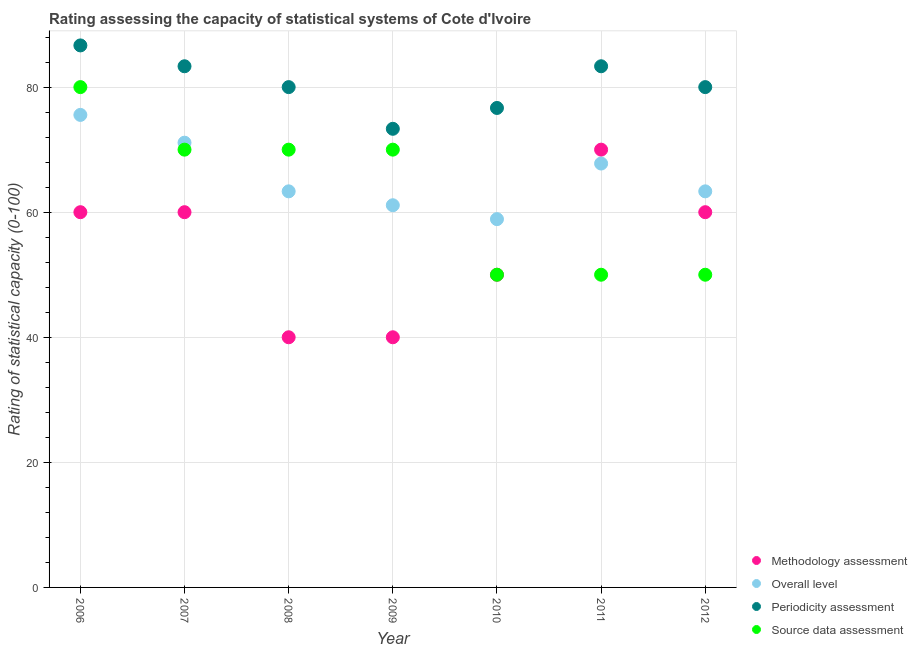How many different coloured dotlines are there?
Your answer should be compact. 4. Is the number of dotlines equal to the number of legend labels?
Provide a succinct answer. Yes. What is the source data assessment rating in 2011?
Make the answer very short. 50. Across all years, what is the maximum methodology assessment rating?
Your answer should be compact. 70. Across all years, what is the minimum source data assessment rating?
Provide a short and direct response. 50. In which year was the methodology assessment rating maximum?
Make the answer very short. 2011. What is the total periodicity assessment rating in the graph?
Make the answer very short. 563.33. What is the difference between the periodicity assessment rating in 2007 and that in 2009?
Keep it short and to the point. 10. What is the difference between the methodology assessment rating in 2011 and the periodicity assessment rating in 2008?
Make the answer very short. -10. What is the average periodicity assessment rating per year?
Give a very brief answer. 80.48. In the year 2009, what is the difference between the overall level rating and methodology assessment rating?
Offer a very short reply. 21.11. In how many years, is the source data assessment rating greater than 20?
Provide a succinct answer. 7. What is the ratio of the source data assessment rating in 2006 to that in 2008?
Your answer should be very brief. 1.14. Is the difference between the source data assessment rating in 2006 and 2008 greater than the difference between the overall level rating in 2006 and 2008?
Your answer should be compact. No. What is the difference between the highest and the second highest overall level rating?
Offer a very short reply. 4.44. What is the difference between the highest and the lowest methodology assessment rating?
Make the answer very short. 30. In how many years, is the source data assessment rating greater than the average source data assessment rating taken over all years?
Your response must be concise. 4. Is the sum of the methodology assessment rating in 2007 and 2012 greater than the maximum overall level rating across all years?
Provide a succinct answer. Yes. Is it the case that in every year, the sum of the methodology assessment rating and overall level rating is greater than the periodicity assessment rating?
Offer a very short reply. Yes. Is the source data assessment rating strictly greater than the periodicity assessment rating over the years?
Keep it short and to the point. No. How many years are there in the graph?
Your answer should be compact. 7. What is the difference between two consecutive major ticks on the Y-axis?
Keep it short and to the point. 20. Are the values on the major ticks of Y-axis written in scientific E-notation?
Offer a very short reply. No. Does the graph contain any zero values?
Your response must be concise. No. Does the graph contain grids?
Give a very brief answer. Yes. How are the legend labels stacked?
Keep it short and to the point. Vertical. What is the title of the graph?
Offer a terse response. Rating assessing the capacity of statistical systems of Cote d'Ivoire. Does "Terrestrial protected areas" appear as one of the legend labels in the graph?
Your answer should be compact. No. What is the label or title of the Y-axis?
Your response must be concise. Rating of statistical capacity (0-100). What is the Rating of statistical capacity (0-100) of Overall level in 2006?
Offer a very short reply. 75.56. What is the Rating of statistical capacity (0-100) in Periodicity assessment in 2006?
Provide a succinct answer. 86.67. What is the Rating of statistical capacity (0-100) of Source data assessment in 2006?
Ensure brevity in your answer.  80. What is the Rating of statistical capacity (0-100) of Overall level in 2007?
Your answer should be compact. 71.11. What is the Rating of statistical capacity (0-100) in Periodicity assessment in 2007?
Provide a succinct answer. 83.33. What is the Rating of statistical capacity (0-100) in Methodology assessment in 2008?
Offer a very short reply. 40. What is the Rating of statistical capacity (0-100) in Overall level in 2008?
Your response must be concise. 63.33. What is the Rating of statistical capacity (0-100) in Periodicity assessment in 2008?
Ensure brevity in your answer.  80. What is the Rating of statistical capacity (0-100) in Overall level in 2009?
Your response must be concise. 61.11. What is the Rating of statistical capacity (0-100) in Periodicity assessment in 2009?
Your answer should be very brief. 73.33. What is the Rating of statistical capacity (0-100) of Overall level in 2010?
Keep it short and to the point. 58.89. What is the Rating of statistical capacity (0-100) of Periodicity assessment in 2010?
Give a very brief answer. 76.67. What is the Rating of statistical capacity (0-100) in Overall level in 2011?
Offer a terse response. 67.78. What is the Rating of statistical capacity (0-100) of Periodicity assessment in 2011?
Offer a very short reply. 83.33. What is the Rating of statistical capacity (0-100) of Source data assessment in 2011?
Your answer should be compact. 50. What is the Rating of statistical capacity (0-100) of Methodology assessment in 2012?
Ensure brevity in your answer.  60. What is the Rating of statistical capacity (0-100) of Overall level in 2012?
Offer a terse response. 63.33. What is the Rating of statistical capacity (0-100) of Periodicity assessment in 2012?
Your answer should be very brief. 80. Across all years, what is the maximum Rating of statistical capacity (0-100) in Methodology assessment?
Your answer should be compact. 70. Across all years, what is the maximum Rating of statistical capacity (0-100) in Overall level?
Provide a short and direct response. 75.56. Across all years, what is the maximum Rating of statistical capacity (0-100) in Periodicity assessment?
Your response must be concise. 86.67. Across all years, what is the minimum Rating of statistical capacity (0-100) of Methodology assessment?
Give a very brief answer. 40. Across all years, what is the minimum Rating of statistical capacity (0-100) in Overall level?
Make the answer very short. 58.89. Across all years, what is the minimum Rating of statistical capacity (0-100) of Periodicity assessment?
Offer a very short reply. 73.33. Across all years, what is the minimum Rating of statistical capacity (0-100) of Source data assessment?
Offer a very short reply. 50. What is the total Rating of statistical capacity (0-100) of Methodology assessment in the graph?
Your response must be concise. 380. What is the total Rating of statistical capacity (0-100) of Overall level in the graph?
Your response must be concise. 461.11. What is the total Rating of statistical capacity (0-100) of Periodicity assessment in the graph?
Your answer should be compact. 563.33. What is the total Rating of statistical capacity (0-100) in Source data assessment in the graph?
Make the answer very short. 440. What is the difference between the Rating of statistical capacity (0-100) in Methodology assessment in 2006 and that in 2007?
Ensure brevity in your answer.  0. What is the difference between the Rating of statistical capacity (0-100) in Overall level in 2006 and that in 2007?
Offer a very short reply. 4.44. What is the difference between the Rating of statistical capacity (0-100) in Periodicity assessment in 2006 and that in 2007?
Your answer should be very brief. 3.33. What is the difference between the Rating of statistical capacity (0-100) of Source data assessment in 2006 and that in 2007?
Keep it short and to the point. 10. What is the difference between the Rating of statistical capacity (0-100) of Overall level in 2006 and that in 2008?
Your answer should be very brief. 12.22. What is the difference between the Rating of statistical capacity (0-100) of Source data assessment in 2006 and that in 2008?
Your response must be concise. 10. What is the difference between the Rating of statistical capacity (0-100) in Overall level in 2006 and that in 2009?
Offer a terse response. 14.44. What is the difference between the Rating of statistical capacity (0-100) in Periodicity assessment in 2006 and that in 2009?
Provide a succinct answer. 13.33. What is the difference between the Rating of statistical capacity (0-100) in Methodology assessment in 2006 and that in 2010?
Ensure brevity in your answer.  10. What is the difference between the Rating of statistical capacity (0-100) in Overall level in 2006 and that in 2010?
Provide a succinct answer. 16.67. What is the difference between the Rating of statistical capacity (0-100) of Source data assessment in 2006 and that in 2010?
Your response must be concise. 30. What is the difference between the Rating of statistical capacity (0-100) of Overall level in 2006 and that in 2011?
Give a very brief answer. 7.78. What is the difference between the Rating of statistical capacity (0-100) in Periodicity assessment in 2006 and that in 2011?
Offer a very short reply. 3.33. What is the difference between the Rating of statistical capacity (0-100) of Source data assessment in 2006 and that in 2011?
Provide a succinct answer. 30. What is the difference between the Rating of statistical capacity (0-100) of Overall level in 2006 and that in 2012?
Your answer should be very brief. 12.22. What is the difference between the Rating of statistical capacity (0-100) in Source data assessment in 2006 and that in 2012?
Give a very brief answer. 30. What is the difference between the Rating of statistical capacity (0-100) in Overall level in 2007 and that in 2008?
Your answer should be very brief. 7.78. What is the difference between the Rating of statistical capacity (0-100) in Periodicity assessment in 2007 and that in 2008?
Offer a very short reply. 3.33. What is the difference between the Rating of statistical capacity (0-100) in Methodology assessment in 2007 and that in 2009?
Offer a terse response. 20. What is the difference between the Rating of statistical capacity (0-100) in Periodicity assessment in 2007 and that in 2009?
Offer a terse response. 10. What is the difference between the Rating of statistical capacity (0-100) in Overall level in 2007 and that in 2010?
Keep it short and to the point. 12.22. What is the difference between the Rating of statistical capacity (0-100) in Periodicity assessment in 2007 and that in 2010?
Ensure brevity in your answer.  6.67. What is the difference between the Rating of statistical capacity (0-100) of Methodology assessment in 2007 and that in 2011?
Provide a short and direct response. -10. What is the difference between the Rating of statistical capacity (0-100) in Source data assessment in 2007 and that in 2011?
Provide a short and direct response. 20. What is the difference between the Rating of statistical capacity (0-100) of Methodology assessment in 2007 and that in 2012?
Keep it short and to the point. 0. What is the difference between the Rating of statistical capacity (0-100) in Overall level in 2007 and that in 2012?
Your answer should be very brief. 7.78. What is the difference between the Rating of statistical capacity (0-100) of Methodology assessment in 2008 and that in 2009?
Keep it short and to the point. 0. What is the difference between the Rating of statistical capacity (0-100) of Overall level in 2008 and that in 2009?
Provide a short and direct response. 2.22. What is the difference between the Rating of statistical capacity (0-100) in Methodology assessment in 2008 and that in 2010?
Your answer should be compact. -10. What is the difference between the Rating of statistical capacity (0-100) of Overall level in 2008 and that in 2010?
Keep it short and to the point. 4.44. What is the difference between the Rating of statistical capacity (0-100) in Periodicity assessment in 2008 and that in 2010?
Offer a terse response. 3.33. What is the difference between the Rating of statistical capacity (0-100) of Methodology assessment in 2008 and that in 2011?
Provide a succinct answer. -30. What is the difference between the Rating of statistical capacity (0-100) in Overall level in 2008 and that in 2011?
Keep it short and to the point. -4.44. What is the difference between the Rating of statistical capacity (0-100) in Source data assessment in 2008 and that in 2011?
Offer a terse response. 20. What is the difference between the Rating of statistical capacity (0-100) in Overall level in 2008 and that in 2012?
Keep it short and to the point. 0. What is the difference between the Rating of statistical capacity (0-100) of Periodicity assessment in 2008 and that in 2012?
Offer a terse response. 0. What is the difference between the Rating of statistical capacity (0-100) in Overall level in 2009 and that in 2010?
Your response must be concise. 2.22. What is the difference between the Rating of statistical capacity (0-100) in Overall level in 2009 and that in 2011?
Offer a terse response. -6.67. What is the difference between the Rating of statistical capacity (0-100) of Periodicity assessment in 2009 and that in 2011?
Make the answer very short. -10. What is the difference between the Rating of statistical capacity (0-100) of Overall level in 2009 and that in 2012?
Provide a short and direct response. -2.22. What is the difference between the Rating of statistical capacity (0-100) in Periodicity assessment in 2009 and that in 2012?
Keep it short and to the point. -6.67. What is the difference between the Rating of statistical capacity (0-100) of Overall level in 2010 and that in 2011?
Your answer should be very brief. -8.89. What is the difference between the Rating of statistical capacity (0-100) of Periodicity assessment in 2010 and that in 2011?
Offer a very short reply. -6.67. What is the difference between the Rating of statistical capacity (0-100) of Overall level in 2010 and that in 2012?
Your answer should be compact. -4.44. What is the difference between the Rating of statistical capacity (0-100) in Periodicity assessment in 2010 and that in 2012?
Keep it short and to the point. -3.33. What is the difference between the Rating of statistical capacity (0-100) in Methodology assessment in 2011 and that in 2012?
Ensure brevity in your answer.  10. What is the difference between the Rating of statistical capacity (0-100) in Overall level in 2011 and that in 2012?
Keep it short and to the point. 4.44. What is the difference between the Rating of statistical capacity (0-100) in Periodicity assessment in 2011 and that in 2012?
Offer a terse response. 3.33. What is the difference between the Rating of statistical capacity (0-100) of Source data assessment in 2011 and that in 2012?
Offer a very short reply. 0. What is the difference between the Rating of statistical capacity (0-100) in Methodology assessment in 2006 and the Rating of statistical capacity (0-100) in Overall level in 2007?
Your answer should be compact. -11.11. What is the difference between the Rating of statistical capacity (0-100) of Methodology assessment in 2006 and the Rating of statistical capacity (0-100) of Periodicity assessment in 2007?
Your response must be concise. -23.33. What is the difference between the Rating of statistical capacity (0-100) of Methodology assessment in 2006 and the Rating of statistical capacity (0-100) of Source data assessment in 2007?
Your response must be concise. -10. What is the difference between the Rating of statistical capacity (0-100) of Overall level in 2006 and the Rating of statistical capacity (0-100) of Periodicity assessment in 2007?
Offer a terse response. -7.78. What is the difference between the Rating of statistical capacity (0-100) of Overall level in 2006 and the Rating of statistical capacity (0-100) of Source data assessment in 2007?
Your response must be concise. 5.56. What is the difference between the Rating of statistical capacity (0-100) in Periodicity assessment in 2006 and the Rating of statistical capacity (0-100) in Source data assessment in 2007?
Offer a terse response. 16.67. What is the difference between the Rating of statistical capacity (0-100) of Methodology assessment in 2006 and the Rating of statistical capacity (0-100) of Overall level in 2008?
Provide a short and direct response. -3.33. What is the difference between the Rating of statistical capacity (0-100) in Methodology assessment in 2006 and the Rating of statistical capacity (0-100) in Periodicity assessment in 2008?
Provide a short and direct response. -20. What is the difference between the Rating of statistical capacity (0-100) of Overall level in 2006 and the Rating of statistical capacity (0-100) of Periodicity assessment in 2008?
Offer a terse response. -4.44. What is the difference between the Rating of statistical capacity (0-100) of Overall level in 2006 and the Rating of statistical capacity (0-100) of Source data assessment in 2008?
Keep it short and to the point. 5.56. What is the difference between the Rating of statistical capacity (0-100) of Periodicity assessment in 2006 and the Rating of statistical capacity (0-100) of Source data assessment in 2008?
Make the answer very short. 16.67. What is the difference between the Rating of statistical capacity (0-100) in Methodology assessment in 2006 and the Rating of statistical capacity (0-100) in Overall level in 2009?
Offer a terse response. -1.11. What is the difference between the Rating of statistical capacity (0-100) of Methodology assessment in 2006 and the Rating of statistical capacity (0-100) of Periodicity assessment in 2009?
Provide a short and direct response. -13.33. What is the difference between the Rating of statistical capacity (0-100) of Overall level in 2006 and the Rating of statistical capacity (0-100) of Periodicity assessment in 2009?
Your answer should be very brief. 2.22. What is the difference between the Rating of statistical capacity (0-100) in Overall level in 2006 and the Rating of statistical capacity (0-100) in Source data assessment in 2009?
Offer a very short reply. 5.56. What is the difference between the Rating of statistical capacity (0-100) of Periodicity assessment in 2006 and the Rating of statistical capacity (0-100) of Source data assessment in 2009?
Ensure brevity in your answer.  16.67. What is the difference between the Rating of statistical capacity (0-100) of Methodology assessment in 2006 and the Rating of statistical capacity (0-100) of Periodicity assessment in 2010?
Your answer should be very brief. -16.67. What is the difference between the Rating of statistical capacity (0-100) in Methodology assessment in 2006 and the Rating of statistical capacity (0-100) in Source data assessment in 2010?
Provide a succinct answer. 10. What is the difference between the Rating of statistical capacity (0-100) in Overall level in 2006 and the Rating of statistical capacity (0-100) in Periodicity assessment in 2010?
Your answer should be very brief. -1.11. What is the difference between the Rating of statistical capacity (0-100) of Overall level in 2006 and the Rating of statistical capacity (0-100) of Source data assessment in 2010?
Provide a succinct answer. 25.56. What is the difference between the Rating of statistical capacity (0-100) of Periodicity assessment in 2006 and the Rating of statistical capacity (0-100) of Source data assessment in 2010?
Ensure brevity in your answer.  36.67. What is the difference between the Rating of statistical capacity (0-100) of Methodology assessment in 2006 and the Rating of statistical capacity (0-100) of Overall level in 2011?
Offer a terse response. -7.78. What is the difference between the Rating of statistical capacity (0-100) of Methodology assessment in 2006 and the Rating of statistical capacity (0-100) of Periodicity assessment in 2011?
Keep it short and to the point. -23.33. What is the difference between the Rating of statistical capacity (0-100) in Methodology assessment in 2006 and the Rating of statistical capacity (0-100) in Source data assessment in 2011?
Provide a succinct answer. 10. What is the difference between the Rating of statistical capacity (0-100) of Overall level in 2006 and the Rating of statistical capacity (0-100) of Periodicity assessment in 2011?
Make the answer very short. -7.78. What is the difference between the Rating of statistical capacity (0-100) in Overall level in 2006 and the Rating of statistical capacity (0-100) in Source data assessment in 2011?
Give a very brief answer. 25.56. What is the difference between the Rating of statistical capacity (0-100) in Periodicity assessment in 2006 and the Rating of statistical capacity (0-100) in Source data assessment in 2011?
Your response must be concise. 36.67. What is the difference between the Rating of statistical capacity (0-100) in Overall level in 2006 and the Rating of statistical capacity (0-100) in Periodicity assessment in 2012?
Ensure brevity in your answer.  -4.44. What is the difference between the Rating of statistical capacity (0-100) in Overall level in 2006 and the Rating of statistical capacity (0-100) in Source data assessment in 2012?
Ensure brevity in your answer.  25.56. What is the difference between the Rating of statistical capacity (0-100) in Periodicity assessment in 2006 and the Rating of statistical capacity (0-100) in Source data assessment in 2012?
Your answer should be very brief. 36.67. What is the difference between the Rating of statistical capacity (0-100) of Methodology assessment in 2007 and the Rating of statistical capacity (0-100) of Overall level in 2008?
Make the answer very short. -3.33. What is the difference between the Rating of statistical capacity (0-100) in Methodology assessment in 2007 and the Rating of statistical capacity (0-100) in Source data assessment in 2008?
Your answer should be very brief. -10. What is the difference between the Rating of statistical capacity (0-100) of Overall level in 2007 and the Rating of statistical capacity (0-100) of Periodicity assessment in 2008?
Your response must be concise. -8.89. What is the difference between the Rating of statistical capacity (0-100) in Overall level in 2007 and the Rating of statistical capacity (0-100) in Source data assessment in 2008?
Provide a succinct answer. 1.11. What is the difference between the Rating of statistical capacity (0-100) in Periodicity assessment in 2007 and the Rating of statistical capacity (0-100) in Source data assessment in 2008?
Give a very brief answer. 13.33. What is the difference between the Rating of statistical capacity (0-100) of Methodology assessment in 2007 and the Rating of statistical capacity (0-100) of Overall level in 2009?
Make the answer very short. -1.11. What is the difference between the Rating of statistical capacity (0-100) of Methodology assessment in 2007 and the Rating of statistical capacity (0-100) of Periodicity assessment in 2009?
Offer a terse response. -13.33. What is the difference between the Rating of statistical capacity (0-100) in Methodology assessment in 2007 and the Rating of statistical capacity (0-100) in Source data assessment in 2009?
Offer a very short reply. -10. What is the difference between the Rating of statistical capacity (0-100) in Overall level in 2007 and the Rating of statistical capacity (0-100) in Periodicity assessment in 2009?
Keep it short and to the point. -2.22. What is the difference between the Rating of statistical capacity (0-100) of Overall level in 2007 and the Rating of statistical capacity (0-100) of Source data assessment in 2009?
Offer a very short reply. 1.11. What is the difference between the Rating of statistical capacity (0-100) of Periodicity assessment in 2007 and the Rating of statistical capacity (0-100) of Source data assessment in 2009?
Offer a very short reply. 13.33. What is the difference between the Rating of statistical capacity (0-100) of Methodology assessment in 2007 and the Rating of statistical capacity (0-100) of Periodicity assessment in 2010?
Your response must be concise. -16.67. What is the difference between the Rating of statistical capacity (0-100) in Overall level in 2007 and the Rating of statistical capacity (0-100) in Periodicity assessment in 2010?
Your response must be concise. -5.56. What is the difference between the Rating of statistical capacity (0-100) of Overall level in 2007 and the Rating of statistical capacity (0-100) of Source data assessment in 2010?
Ensure brevity in your answer.  21.11. What is the difference between the Rating of statistical capacity (0-100) of Periodicity assessment in 2007 and the Rating of statistical capacity (0-100) of Source data assessment in 2010?
Your answer should be compact. 33.33. What is the difference between the Rating of statistical capacity (0-100) of Methodology assessment in 2007 and the Rating of statistical capacity (0-100) of Overall level in 2011?
Make the answer very short. -7.78. What is the difference between the Rating of statistical capacity (0-100) of Methodology assessment in 2007 and the Rating of statistical capacity (0-100) of Periodicity assessment in 2011?
Keep it short and to the point. -23.33. What is the difference between the Rating of statistical capacity (0-100) of Methodology assessment in 2007 and the Rating of statistical capacity (0-100) of Source data assessment in 2011?
Provide a succinct answer. 10. What is the difference between the Rating of statistical capacity (0-100) in Overall level in 2007 and the Rating of statistical capacity (0-100) in Periodicity assessment in 2011?
Provide a short and direct response. -12.22. What is the difference between the Rating of statistical capacity (0-100) of Overall level in 2007 and the Rating of statistical capacity (0-100) of Source data assessment in 2011?
Your response must be concise. 21.11. What is the difference between the Rating of statistical capacity (0-100) in Periodicity assessment in 2007 and the Rating of statistical capacity (0-100) in Source data assessment in 2011?
Offer a terse response. 33.33. What is the difference between the Rating of statistical capacity (0-100) in Overall level in 2007 and the Rating of statistical capacity (0-100) in Periodicity assessment in 2012?
Your response must be concise. -8.89. What is the difference between the Rating of statistical capacity (0-100) of Overall level in 2007 and the Rating of statistical capacity (0-100) of Source data assessment in 2012?
Your answer should be compact. 21.11. What is the difference between the Rating of statistical capacity (0-100) of Periodicity assessment in 2007 and the Rating of statistical capacity (0-100) of Source data assessment in 2012?
Your answer should be compact. 33.33. What is the difference between the Rating of statistical capacity (0-100) of Methodology assessment in 2008 and the Rating of statistical capacity (0-100) of Overall level in 2009?
Keep it short and to the point. -21.11. What is the difference between the Rating of statistical capacity (0-100) in Methodology assessment in 2008 and the Rating of statistical capacity (0-100) in Periodicity assessment in 2009?
Make the answer very short. -33.33. What is the difference between the Rating of statistical capacity (0-100) in Methodology assessment in 2008 and the Rating of statistical capacity (0-100) in Source data assessment in 2009?
Your answer should be compact. -30. What is the difference between the Rating of statistical capacity (0-100) of Overall level in 2008 and the Rating of statistical capacity (0-100) of Periodicity assessment in 2009?
Provide a short and direct response. -10. What is the difference between the Rating of statistical capacity (0-100) in Overall level in 2008 and the Rating of statistical capacity (0-100) in Source data assessment in 2009?
Your answer should be very brief. -6.67. What is the difference between the Rating of statistical capacity (0-100) in Periodicity assessment in 2008 and the Rating of statistical capacity (0-100) in Source data assessment in 2009?
Give a very brief answer. 10. What is the difference between the Rating of statistical capacity (0-100) in Methodology assessment in 2008 and the Rating of statistical capacity (0-100) in Overall level in 2010?
Provide a succinct answer. -18.89. What is the difference between the Rating of statistical capacity (0-100) of Methodology assessment in 2008 and the Rating of statistical capacity (0-100) of Periodicity assessment in 2010?
Keep it short and to the point. -36.67. What is the difference between the Rating of statistical capacity (0-100) in Overall level in 2008 and the Rating of statistical capacity (0-100) in Periodicity assessment in 2010?
Provide a succinct answer. -13.33. What is the difference between the Rating of statistical capacity (0-100) in Overall level in 2008 and the Rating of statistical capacity (0-100) in Source data assessment in 2010?
Make the answer very short. 13.33. What is the difference between the Rating of statistical capacity (0-100) in Methodology assessment in 2008 and the Rating of statistical capacity (0-100) in Overall level in 2011?
Give a very brief answer. -27.78. What is the difference between the Rating of statistical capacity (0-100) of Methodology assessment in 2008 and the Rating of statistical capacity (0-100) of Periodicity assessment in 2011?
Offer a terse response. -43.33. What is the difference between the Rating of statistical capacity (0-100) in Overall level in 2008 and the Rating of statistical capacity (0-100) in Source data assessment in 2011?
Keep it short and to the point. 13.33. What is the difference between the Rating of statistical capacity (0-100) in Periodicity assessment in 2008 and the Rating of statistical capacity (0-100) in Source data assessment in 2011?
Ensure brevity in your answer.  30. What is the difference between the Rating of statistical capacity (0-100) of Methodology assessment in 2008 and the Rating of statistical capacity (0-100) of Overall level in 2012?
Offer a terse response. -23.33. What is the difference between the Rating of statistical capacity (0-100) in Overall level in 2008 and the Rating of statistical capacity (0-100) in Periodicity assessment in 2012?
Make the answer very short. -16.67. What is the difference between the Rating of statistical capacity (0-100) in Overall level in 2008 and the Rating of statistical capacity (0-100) in Source data assessment in 2012?
Your answer should be very brief. 13.33. What is the difference between the Rating of statistical capacity (0-100) in Methodology assessment in 2009 and the Rating of statistical capacity (0-100) in Overall level in 2010?
Keep it short and to the point. -18.89. What is the difference between the Rating of statistical capacity (0-100) in Methodology assessment in 2009 and the Rating of statistical capacity (0-100) in Periodicity assessment in 2010?
Your response must be concise. -36.67. What is the difference between the Rating of statistical capacity (0-100) in Overall level in 2009 and the Rating of statistical capacity (0-100) in Periodicity assessment in 2010?
Offer a very short reply. -15.56. What is the difference between the Rating of statistical capacity (0-100) of Overall level in 2009 and the Rating of statistical capacity (0-100) of Source data assessment in 2010?
Your answer should be very brief. 11.11. What is the difference between the Rating of statistical capacity (0-100) in Periodicity assessment in 2009 and the Rating of statistical capacity (0-100) in Source data assessment in 2010?
Your answer should be compact. 23.33. What is the difference between the Rating of statistical capacity (0-100) of Methodology assessment in 2009 and the Rating of statistical capacity (0-100) of Overall level in 2011?
Give a very brief answer. -27.78. What is the difference between the Rating of statistical capacity (0-100) in Methodology assessment in 2009 and the Rating of statistical capacity (0-100) in Periodicity assessment in 2011?
Your answer should be very brief. -43.33. What is the difference between the Rating of statistical capacity (0-100) of Methodology assessment in 2009 and the Rating of statistical capacity (0-100) of Source data assessment in 2011?
Ensure brevity in your answer.  -10. What is the difference between the Rating of statistical capacity (0-100) in Overall level in 2009 and the Rating of statistical capacity (0-100) in Periodicity assessment in 2011?
Offer a very short reply. -22.22. What is the difference between the Rating of statistical capacity (0-100) of Overall level in 2009 and the Rating of statistical capacity (0-100) of Source data assessment in 2011?
Your response must be concise. 11.11. What is the difference between the Rating of statistical capacity (0-100) of Periodicity assessment in 2009 and the Rating of statistical capacity (0-100) of Source data assessment in 2011?
Keep it short and to the point. 23.33. What is the difference between the Rating of statistical capacity (0-100) in Methodology assessment in 2009 and the Rating of statistical capacity (0-100) in Overall level in 2012?
Keep it short and to the point. -23.33. What is the difference between the Rating of statistical capacity (0-100) in Methodology assessment in 2009 and the Rating of statistical capacity (0-100) in Periodicity assessment in 2012?
Keep it short and to the point. -40. What is the difference between the Rating of statistical capacity (0-100) of Overall level in 2009 and the Rating of statistical capacity (0-100) of Periodicity assessment in 2012?
Offer a very short reply. -18.89. What is the difference between the Rating of statistical capacity (0-100) in Overall level in 2009 and the Rating of statistical capacity (0-100) in Source data assessment in 2012?
Keep it short and to the point. 11.11. What is the difference between the Rating of statistical capacity (0-100) of Periodicity assessment in 2009 and the Rating of statistical capacity (0-100) of Source data assessment in 2012?
Your response must be concise. 23.33. What is the difference between the Rating of statistical capacity (0-100) in Methodology assessment in 2010 and the Rating of statistical capacity (0-100) in Overall level in 2011?
Make the answer very short. -17.78. What is the difference between the Rating of statistical capacity (0-100) of Methodology assessment in 2010 and the Rating of statistical capacity (0-100) of Periodicity assessment in 2011?
Offer a terse response. -33.33. What is the difference between the Rating of statistical capacity (0-100) of Methodology assessment in 2010 and the Rating of statistical capacity (0-100) of Source data assessment in 2011?
Provide a succinct answer. 0. What is the difference between the Rating of statistical capacity (0-100) in Overall level in 2010 and the Rating of statistical capacity (0-100) in Periodicity assessment in 2011?
Your response must be concise. -24.44. What is the difference between the Rating of statistical capacity (0-100) of Overall level in 2010 and the Rating of statistical capacity (0-100) of Source data assessment in 2011?
Give a very brief answer. 8.89. What is the difference between the Rating of statistical capacity (0-100) in Periodicity assessment in 2010 and the Rating of statistical capacity (0-100) in Source data assessment in 2011?
Ensure brevity in your answer.  26.67. What is the difference between the Rating of statistical capacity (0-100) of Methodology assessment in 2010 and the Rating of statistical capacity (0-100) of Overall level in 2012?
Offer a terse response. -13.33. What is the difference between the Rating of statistical capacity (0-100) in Methodology assessment in 2010 and the Rating of statistical capacity (0-100) in Periodicity assessment in 2012?
Offer a terse response. -30. What is the difference between the Rating of statistical capacity (0-100) of Overall level in 2010 and the Rating of statistical capacity (0-100) of Periodicity assessment in 2012?
Give a very brief answer. -21.11. What is the difference between the Rating of statistical capacity (0-100) of Overall level in 2010 and the Rating of statistical capacity (0-100) of Source data assessment in 2012?
Provide a succinct answer. 8.89. What is the difference between the Rating of statistical capacity (0-100) in Periodicity assessment in 2010 and the Rating of statistical capacity (0-100) in Source data assessment in 2012?
Offer a very short reply. 26.67. What is the difference between the Rating of statistical capacity (0-100) of Methodology assessment in 2011 and the Rating of statistical capacity (0-100) of Overall level in 2012?
Offer a very short reply. 6.67. What is the difference between the Rating of statistical capacity (0-100) of Methodology assessment in 2011 and the Rating of statistical capacity (0-100) of Periodicity assessment in 2012?
Provide a short and direct response. -10. What is the difference between the Rating of statistical capacity (0-100) of Methodology assessment in 2011 and the Rating of statistical capacity (0-100) of Source data assessment in 2012?
Give a very brief answer. 20. What is the difference between the Rating of statistical capacity (0-100) in Overall level in 2011 and the Rating of statistical capacity (0-100) in Periodicity assessment in 2012?
Keep it short and to the point. -12.22. What is the difference between the Rating of statistical capacity (0-100) of Overall level in 2011 and the Rating of statistical capacity (0-100) of Source data assessment in 2012?
Provide a short and direct response. 17.78. What is the difference between the Rating of statistical capacity (0-100) of Periodicity assessment in 2011 and the Rating of statistical capacity (0-100) of Source data assessment in 2012?
Your answer should be compact. 33.33. What is the average Rating of statistical capacity (0-100) of Methodology assessment per year?
Your answer should be compact. 54.29. What is the average Rating of statistical capacity (0-100) in Overall level per year?
Offer a terse response. 65.87. What is the average Rating of statistical capacity (0-100) of Periodicity assessment per year?
Your answer should be compact. 80.48. What is the average Rating of statistical capacity (0-100) in Source data assessment per year?
Your answer should be very brief. 62.86. In the year 2006, what is the difference between the Rating of statistical capacity (0-100) of Methodology assessment and Rating of statistical capacity (0-100) of Overall level?
Offer a terse response. -15.56. In the year 2006, what is the difference between the Rating of statistical capacity (0-100) of Methodology assessment and Rating of statistical capacity (0-100) of Periodicity assessment?
Give a very brief answer. -26.67. In the year 2006, what is the difference between the Rating of statistical capacity (0-100) in Overall level and Rating of statistical capacity (0-100) in Periodicity assessment?
Your response must be concise. -11.11. In the year 2006, what is the difference between the Rating of statistical capacity (0-100) of Overall level and Rating of statistical capacity (0-100) of Source data assessment?
Keep it short and to the point. -4.44. In the year 2006, what is the difference between the Rating of statistical capacity (0-100) in Periodicity assessment and Rating of statistical capacity (0-100) in Source data assessment?
Your answer should be compact. 6.67. In the year 2007, what is the difference between the Rating of statistical capacity (0-100) in Methodology assessment and Rating of statistical capacity (0-100) in Overall level?
Ensure brevity in your answer.  -11.11. In the year 2007, what is the difference between the Rating of statistical capacity (0-100) in Methodology assessment and Rating of statistical capacity (0-100) in Periodicity assessment?
Your response must be concise. -23.33. In the year 2007, what is the difference between the Rating of statistical capacity (0-100) in Overall level and Rating of statistical capacity (0-100) in Periodicity assessment?
Your response must be concise. -12.22. In the year 2007, what is the difference between the Rating of statistical capacity (0-100) in Overall level and Rating of statistical capacity (0-100) in Source data assessment?
Your answer should be compact. 1.11. In the year 2007, what is the difference between the Rating of statistical capacity (0-100) of Periodicity assessment and Rating of statistical capacity (0-100) of Source data assessment?
Offer a terse response. 13.33. In the year 2008, what is the difference between the Rating of statistical capacity (0-100) in Methodology assessment and Rating of statistical capacity (0-100) in Overall level?
Make the answer very short. -23.33. In the year 2008, what is the difference between the Rating of statistical capacity (0-100) of Methodology assessment and Rating of statistical capacity (0-100) of Periodicity assessment?
Keep it short and to the point. -40. In the year 2008, what is the difference between the Rating of statistical capacity (0-100) of Overall level and Rating of statistical capacity (0-100) of Periodicity assessment?
Offer a very short reply. -16.67. In the year 2008, what is the difference between the Rating of statistical capacity (0-100) of Overall level and Rating of statistical capacity (0-100) of Source data assessment?
Keep it short and to the point. -6.67. In the year 2008, what is the difference between the Rating of statistical capacity (0-100) in Periodicity assessment and Rating of statistical capacity (0-100) in Source data assessment?
Ensure brevity in your answer.  10. In the year 2009, what is the difference between the Rating of statistical capacity (0-100) in Methodology assessment and Rating of statistical capacity (0-100) in Overall level?
Keep it short and to the point. -21.11. In the year 2009, what is the difference between the Rating of statistical capacity (0-100) of Methodology assessment and Rating of statistical capacity (0-100) of Periodicity assessment?
Make the answer very short. -33.33. In the year 2009, what is the difference between the Rating of statistical capacity (0-100) of Methodology assessment and Rating of statistical capacity (0-100) of Source data assessment?
Ensure brevity in your answer.  -30. In the year 2009, what is the difference between the Rating of statistical capacity (0-100) of Overall level and Rating of statistical capacity (0-100) of Periodicity assessment?
Provide a succinct answer. -12.22. In the year 2009, what is the difference between the Rating of statistical capacity (0-100) of Overall level and Rating of statistical capacity (0-100) of Source data assessment?
Keep it short and to the point. -8.89. In the year 2009, what is the difference between the Rating of statistical capacity (0-100) in Periodicity assessment and Rating of statistical capacity (0-100) in Source data assessment?
Offer a very short reply. 3.33. In the year 2010, what is the difference between the Rating of statistical capacity (0-100) in Methodology assessment and Rating of statistical capacity (0-100) in Overall level?
Give a very brief answer. -8.89. In the year 2010, what is the difference between the Rating of statistical capacity (0-100) of Methodology assessment and Rating of statistical capacity (0-100) of Periodicity assessment?
Ensure brevity in your answer.  -26.67. In the year 2010, what is the difference between the Rating of statistical capacity (0-100) in Overall level and Rating of statistical capacity (0-100) in Periodicity assessment?
Make the answer very short. -17.78. In the year 2010, what is the difference between the Rating of statistical capacity (0-100) in Overall level and Rating of statistical capacity (0-100) in Source data assessment?
Ensure brevity in your answer.  8.89. In the year 2010, what is the difference between the Rating of statistical capacity (0-100) in Periodicity assessment and Rating of statistical capacity (0-100) in Source data assessment?
Offer a terse response. 26.67. In the year 2011, what is the difference between the Rating of statistical capacity (0-100) of Methodology assessment and Rating of statistical capacity (0-100) of Overall level?
Your answer should be compact. 2.22. In the year 2011, what is the difference between the Rating of statistical capacity (0-100) of Methodology assessment and Rating of statistical capacity (0-100) of Periodicity assessment?
Provide a succinct answer. -13.33. In the year 2011, what is the difference between the Rating of statistical capacity (0-100) of Overall level and Rating of statistical capacity (0-100) of Periodicity assessment?
Offer a terse response. -15.56. In the year 2011, what is the difference between the Rating of statistical capacity (0-100) in Overall level and Rating of statistical capacity (0-100) in Source data assessment?
Your response must be concise. 17.78. In the year 2011, what is the difference between the Rating of statistical capacity (0-100) of Periodicity assessment and Rating of statistical capacity (0-100) of Source data assessment?
Keep it short and to the point. 33.33. In the year 2012, what is the difference between the Rating of statistical capacity (0-100) of Methodology assessment and Rating of statistical capacity (0-100) of Overall level?
Keep it short and to the point. -3.33. In the year 2012, what is the difference between the Rating of statistical capacity (0-100) in Methodology assessment and Rating of statistical capacity (0-100) in Periodicity assessment?
Provide a succinct answer. -20. In the year 2012, what is the difference between the Rating of statistical capacity (0-100) in Overall level and Rating of statistical capacity (0-100) in Periodicity assessment?
Your response must be concise. -16.67. In the year 2012, what is the difference between the Rating of statistical capacity (0-100) in Overall level and Rating of statistical capacity (0-100) in Source data assessment?
Your answer should be compact. 13.33. In the year 2012, what is the difference between the Rating of statistical capacity (0-100) in Periodicity assessment and Rating of statistical capacity (0-100) in Source data assessment?
Provide a short and direct response. 30. What is the ratio of the Rating of statistical capacity (0-100) of Methodology assessment in 2006 to that in 2007?
Your response must be concise. 1. What is the ratio of the Rating of statistical capacity (0-100) of Periodicity assessment in 2006 to that in 2007?
Your response must be concise. 1.04. What is the ratio of the Rating of statistical capacity (0-100) in Source data assessment in 2006 to that in 2007?
Your answer should be very brief. 1.14. What is the ratio of the Rating of statistical capacity (0-100) of Overall level in 2006 to that in 2008?
Offer a very short reply. 1.19. What is the ratio of the Rating of statistical capacity (0-100) of Source data assessment in 2006 to that in 2008?
Your answer should be compact. 1.14. What is the ratio of the Rating of statistical capacity (0-100) of Overall level in 2006 to that in 2009?
Offer a terse response. 1.24. What is the ratio of the Rating of statistical capacity (0-100) of Periodicity assessment in 2006 to that in 2009?
Make the answer very short. 1.18. What is the ratio of the Rating of statistical capacity (0-100) of Overall level in 2006 to that in 2010?
Keep it short and to the point. 1.28. What is the ratio of the Rating of statistical capacity (0-100) in Periodicity assessment in 2006 to that in 2010?
Offer a terse response. 1.13. What is the ratio of the Rating of statistical capacity (0-100) in Overall level in 2006 to that in 2011?
Offer a very short reply. 1.11. What is the ratio of the Rating of statistical capacity (0-100) of Periodicity assessment in 2006 to that in 2011?
Your answer should be compact. 1.04. What is the ratio of the Rating of statistical capacity (0-100) in Source data assessment in 2006 to that in 2011?
Offer a very short reply. 1.6. What is the ratio of the Rating of statistical capacity (0-100) of Overall level in 2006 to that in 2012?
Keep it short and to the point. 1.19. What is the ratio of the Rating of statistical capacity (0-100) in Periodicity assessment in 2006 to that in 2012?
Provide a succinct answer. 1.08. What is the ratio of the Rating of statistical capacity (0-100) of Overall level in 2007 to that in 2008?
Your response must be concise. 1.12. What is the ratio of the Rating of statistical capacity (0-100) of Periodicity assessment in 2007 to that in 2008?
Your answer should be very brief. 1.04. What is the ratio of the Rating of statistical capacity (0-100) of Source data assessment in 2007 to that in 2008?
Keep it short and to the point. 1. What is the ratio of the Rating of statistical capacity (0-100) of Overall level in 2007 to that in 2009?
Provide a short and direct response. 1.16. What is the ratio of the Rating of statistical capacity (0-100) in Periodicity assessment in 2007 to that in 2009?
Provide a succinct answer. 1.14. What is the ratio of the Rating of statistical capacity (0-100) in Methodology assessment in 2007 to that in 2010?
Your answer should be very brief. 1.2. What is the ratio of the Rating of statistical capacity (0-100) of Overall level in 2007 to that in 2010?
Your answer should be very brief. 1.21. What is the ratio of the Rating of statistical capacity (0-100) in Periodicity assessment in 2007 to that in 2010?
Your answer should be compact. 1.09. What is the ratio of the Rating of statistical capacity (0-100) in Source data assessment in 2007 to that in 2010?
Provide a succinct answer. 1.4. What is the ratio of the Rating of statistical capacity (0-100) of Overall level in 2007 to that in 2011?
Provide a short and direct response. 1.05. What is the ratio of the Rating of statistical capacity (0-100) in Periodicity assessment in 2007 to that in 2011?
Offer a terse response. 1. What is the ratio of the Rating of statistical capacity (0-100) of Source data assessment in 2007 to that in 2011?
Offer a very short reply. 1.4. What is the ratio of the Rating of statistical capacity (0-100) in Overall level in 2007 to that in 2012?
Give a very brief answer. 1.12. What is the ratio of the Rating of statistical capacity (0-100) in Periodicity assessment in 2007 to that in 2012?
Your answer should be very brief. 1.04. What is the ratio of the Rating of statistical capacity (0-100) of Source data assessment in 2007 to that in 2012?
Your response must be concise. 1.4. What is the ratio of the Rating of statistical capacity (0-100) in Overall level in 2008 to that in 2009?
Your response must be concise. 1.04. What is the ratio of the Rating of statistical capacity (0-100) in Overall level in 2008 to that in 2010?
Offer a terse response. 1.08. What is the ratio of the Rating of statistical capacity (0-100) of Periodicity assessment in 2008 to that in 2010?
Offer a very short reply. 1.04. What is the ratio of the Rating of statistical capacity (0-100) of Source data assessment in 2008 to that in 2010?
Provide a short and direct response. 1.4. What is the ratio of the Rating of statistical capacity (0-100) in Overall level in 2008 to that in 2011?
Ensure brevity in your answer.  0.93. What is the ratio of the Rating of statistical capacity (0-100) of Source data assessment in 2008 to that in 2011?
Your response must be concise. 1.4. What is the ratio of the Rating of statistical capacity (0-100) of Methodology assessment in 2008 to that in 2012?
Ensure brevity in your answer.  0.67. What is the ratio of the Rating of statistical capacity (0-100) in Overall level in 2009 to that in 2010?
Offer a very short reply. 1.04. What is the ratio of the Rating of statistical capacity (0-100) in Periodicity assessment in 2009 to that in 2010?
Your response must be concise. 0.96. What is the ratio of the Rating of statistical capacity (0-100) in Source data assessment in 2009 to that in 2010?
Provide a short and direct response. 1.4. What is the ratio of the Rating of statistical capacity (0-100) in Methodology assessment in 2009 to that in 2011?
Your answer should be compact. 0.57. What is the ratio of the Rating of statistical capacity (0-100) of Overall level in 2009 to that in 2011?
Provide a succinct answer. 0.9. What is the ratio of the Rating of statistical capacity (0-100) in Periodicity assessment in 2009 to that in 2011?
Your answer should be compact. 0.88. What is the ratio of the Rating of statistical capacity (0-100) of Source data assessment in 2009 to that in 2011?
Your answer should be very brief. 1.4. What is the ratio of the Rating of statistical capacity (0-100) of Overall level in 2009 to that in 2012?
Ensure brevity in your answer.  0.96. What is the ratio of the Rating of statistical capacity (0-100) in Periodicity assessment in 2009 to that in 2012?
Provide a succinct answer. 0.92. What is the ratio of the Rating of statistical capacity (0-100) in Source data assessment in 2009 to that in 2012?
Keep it short and to the point. 1.4. What is the ratio of the Rating of statistical capacity (0-100) in Overall level in 2010 to that in 2011?
Your answer should be very brief. 0.87. What is the ratio of the Rating of statistical capacity (0-100) of Overall level in 2010 to that in 2012?
Ensure brevity in your answer.  0.93. What is the ratio of the Rating of statistical capacity (0-100) of Periodicity assessment in 2010 to that in 2012?
Offer a very short reply. 0.96. What is the ratio of the Rating of statistical capacity (0-100) of Overall level in 2011 to that in 2012?
Offer a very short reply. 1.07. What is the ratio of the Rating of statistical capacity (0-100) of Periodicity assessment in 2011 to that in 2012?
Your answer should be very brief. 1.04. What is the difference between the highest and the second highest Rating of statistical capacity (0-100) of Overall level?
Your answer should be compact. 4.44. What is the difference between the highest and the lowest Rating of statistical capacity (0-100) of Overall level?
Make the answer very short. 16.67. What is the difference between the highest and the lowest Rating of statistical capacity (0-100) of Periodicity assessment?
Provide a succinct answer. 13.33. 